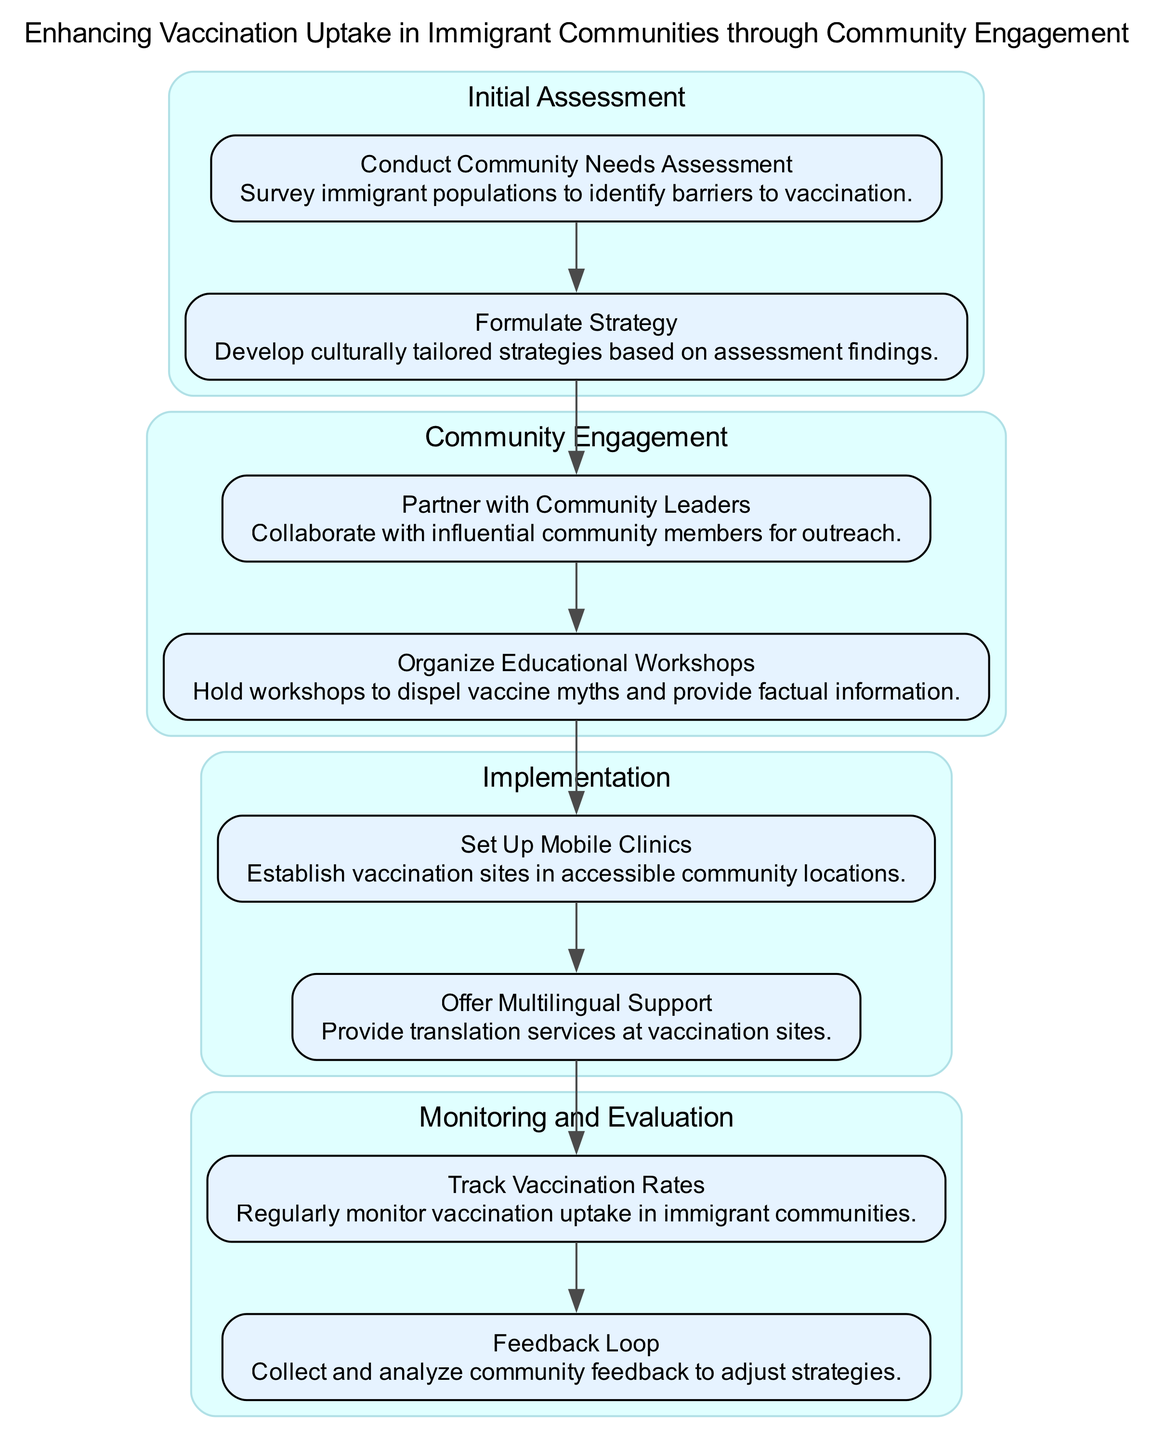What is the title of the clinical pathway? The title is provided at the top of the diagram and reads "Enhancing Vaccination Uptake in Immigrant Communities through Community Engagement."
Answer: Enhancing Vaccination Uptake in Immigrant Communities through Community Engagement How many stages are in the clinical pathway? By analyzing the diagram, we can observe that there are four distinct stages present in the clinical pathway: Initial Assessment, Community Engagement, Implementation, and Monitoring and Evaluation.
Answer: 4 What action is taken in the Initial Assessment stage? In the Initial Assessment stage, the actions taken include "Conduct Community Needs Assessment" and "Formulate Strategy," with the first action focusing on surveying immigrant populations.
Answer: Conduct Community Needs Assessment Which stage follows Community Engagement? The question asks for the stage that directly follows Community Engagement in the flow of the diagram. Observing the order, we find that Implementation is the stage that follows Community Engagement.
Answer: Implementation What is one element of the Implementation stage? The Implementation stage contains several elements. One example is "Set Up Mobile Clinics," which indicates the setup of vaccination sites in community locations.
Answer: Set Up Mobile Clinics What two actions are included in the Monitoring and Evaluation stage? In the Monitoring and Evaluation stage, we can find two actions: "Track Vaccination Rates" and "Feedback Loop." These actions focus on monitoring vaccination uptake and collecting community feedback.
Answer: Track Vaccination Rates, Feedback Loop Who should community organizations partner with during Community Engagement? During Community Engagement, community organizations should partner with "Community Leaders," who are described as influential members for effective outreach.
Answer: Community Leaders How does feedback influence the clinical pathway? Feedback influences the clinical pathway by creating a "Feedback Loop" that collects and analyzes community feedback to adjust strategies, thus ensuring the pathway remains effective.
Answer: Feedback Loop What is the purpose of offering multilingual support in the Implementation stage? The purpose of offering multilingual support is to "Provide translation services at vaccination sites," enabling better communication and access for diverse immigrant populations.
Answer: Provide translation services at vaccination sites 